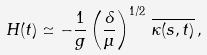<formula> <loc_0><loc_0><loc_500><loc_500>H ( t ) \simeq - \frac { 1 } { g } \left ( \frac { \delta } { \mu } \right ) ^ { 1 / 2 } \, \overline { \kappa ( s , t ) } \, ,</formula> 